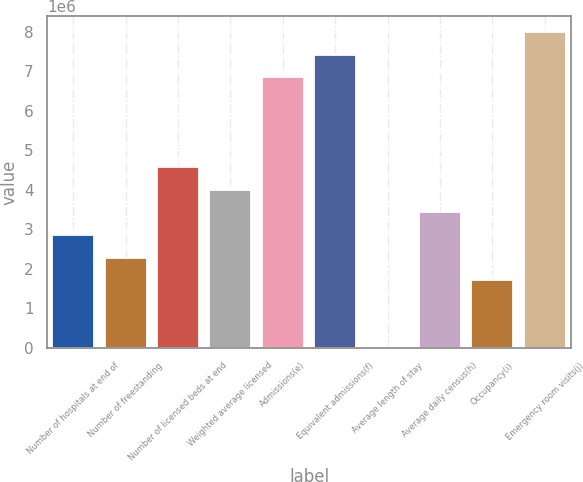Convert chart. <chart><loc_0><loc_0><loc_500><loc_500><bar_chart><fcel>Number of hospitals at end of<fcel>Number of freestanding<fcel>Number of licensed beds at end<fcel>Weighted average licensed<fcel>Admissions(e)<fcel>Equivalent admissions(f)<fcel>Average length of stay<fcel>Average daily census(h)<fcel>Occupancy(i)<fcel>Emergency room visits(j)<nl><fcel>2.8531e+06<fcel>2.28248e+06<fcel>4.56496e+06<fcel>3.99434e+06<fcel>6.84744e+06<fcel>7.41806e+06<fcel>4.8<fcel>3.42372e+06<fcel>1.71186e+06<fcel>7.98868e+06<nl></chart> 